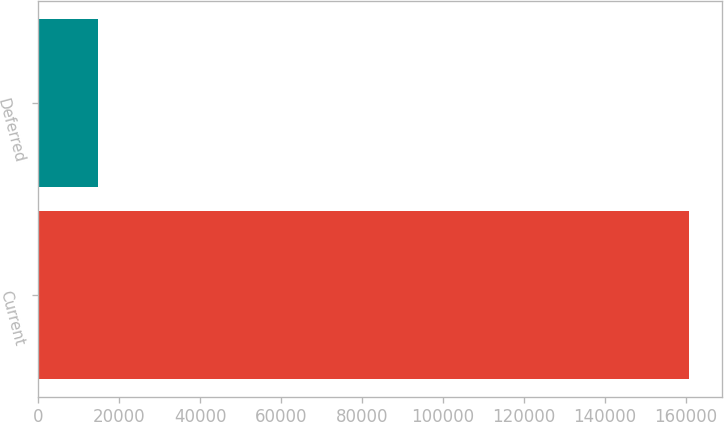<chart> <loc_0><loc_0><loc_500><loc_500><bar_chart><fcel>Current<fcel>Deferred<nl><fcel>160858<fcel>14903<nl></chart> 